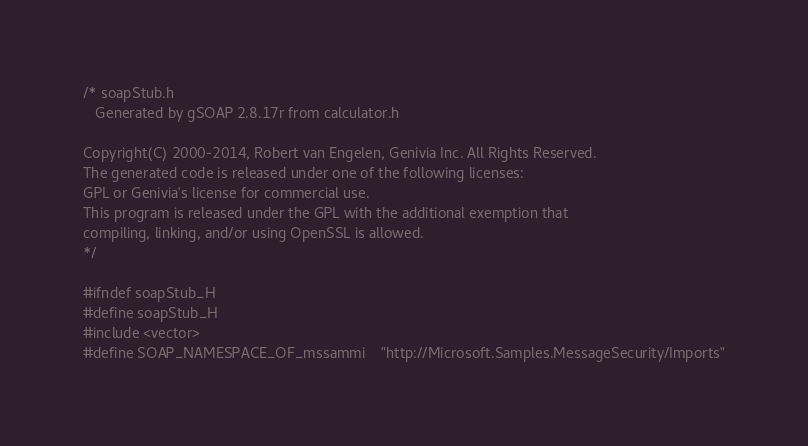Convert code to text. <code><loc_0><loc_0><loc_500><loc_500><_C_>/* soapStub.h
   Generated by gSOAP 2.8.17r from calculator.h

Copyright(C) 2000-2014, Robert van Engelen, Genivia Inc. All Rights Reserved.
The generated code is released under one of the following licenses:
GPL or Genivia's license for commercial use.
This program is released under the GPL with the additional exemption that
compiling, linking, and/or using OpenSSL is allowed.
*/

#ifndef soapStub_H
#define soapStub_H
#include <vector>
#define SOAP_NAMESPACE_OF_mssammi	"http://Microsoft.Samples.MessageSecurity/Imports"</code> 